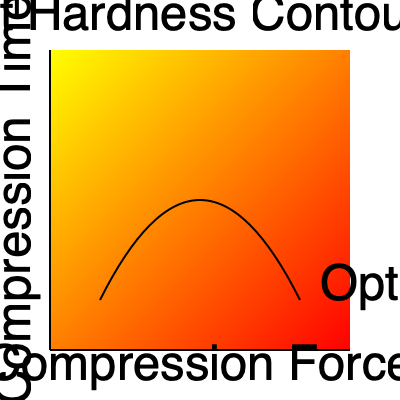Based on the contour plot of tablet hardness vs. compression force and time, what does the curved black line represent, and how would you use this information to optimize the tablet compression process? 1. Interpretation of the contour plot:
   - The x-axis represents compression force
   - The y-axis represents compression time
   - The color gradient represents tablet hardness (yellow to red indicating increasing hardness)

2. The curved black line:
   - This line represents the optimal combination of compression force and time
   - Along this line, the tablet hardness is maximized for given force-time combinations

3. Optimization process:
   - The goal is to achieve the desired tablet hardness while minimizing production time and energy consumption
   - The optimal line provides a range of force-time combinations that yield maximum hardness

4. Using the information:
   - Choose a point on the optimal line that balances compression force and time
   - Lower force and longer time may be preferred for sensitive formulations
   - Higher force and shorter time may be preferred for higher throughput

5. Practical application:
   - Start with the midpoint of the optimal line
   - Adjust force and time based on specific formulation requirements and production constraints
   - Fine-tune parameters through experimental validation

6. Considerations:
   - Material properties of the formulation
   - Equipment capabilities and limitations
   - Production scale and efficiency requirements

7. Continuous improvement:
   - Regularly update the contour plot with new data
   - Use statistical process control to maintain optimal conditions
Answer: The curved black line represents the optimal combination of compression force and time for maximum tablet hardness. Use it to select force-time parameters that balance hardness, production efficiency, and formulation requirements. 